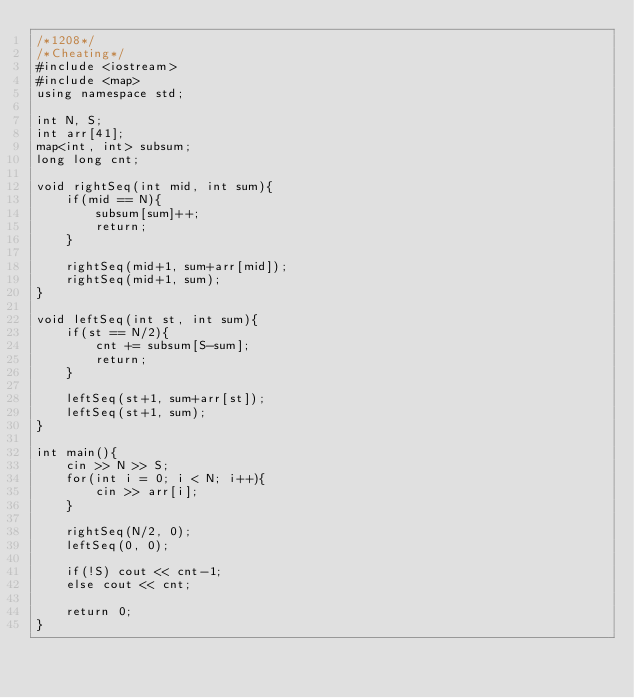Convert code to text. <code><loc_0><loc_0><loc_500><loc_500><_C++_>/*1208*/
/*Cheating*/
#include <iostream>
#include <map>
using namespace std;
 
int N, S;
int arr[41];
map<int, int> subsum;
long long cnt;
 
void rightSeq(int mid, int sum){
    if(mid == N){
        subsum[sum]++;
        return;
    }
    
    rightSeq(mid+1, sum+arr[mid]);
    rightSeq(mid+1, sum);
}
 
void leftSeq(int st, int sum){
    if(st == N/2){
        cnt += subsum[S-sum];
        return;
    }
    
    leftSeq(st+1, sum+arr[st]);
    leftSeq(st+1, sum);
}
 
int main(){
    cin >> N >> S;
    for(int i = 0; i < N; i++){
        cin >> arr[i];
    }
    
    rightSeq(N/2, 0);
    leftSeq(0, 0);
    
    if(!S) cout << cnt-1;
    else cout << cnt;
    
    return 0;
}</code> 